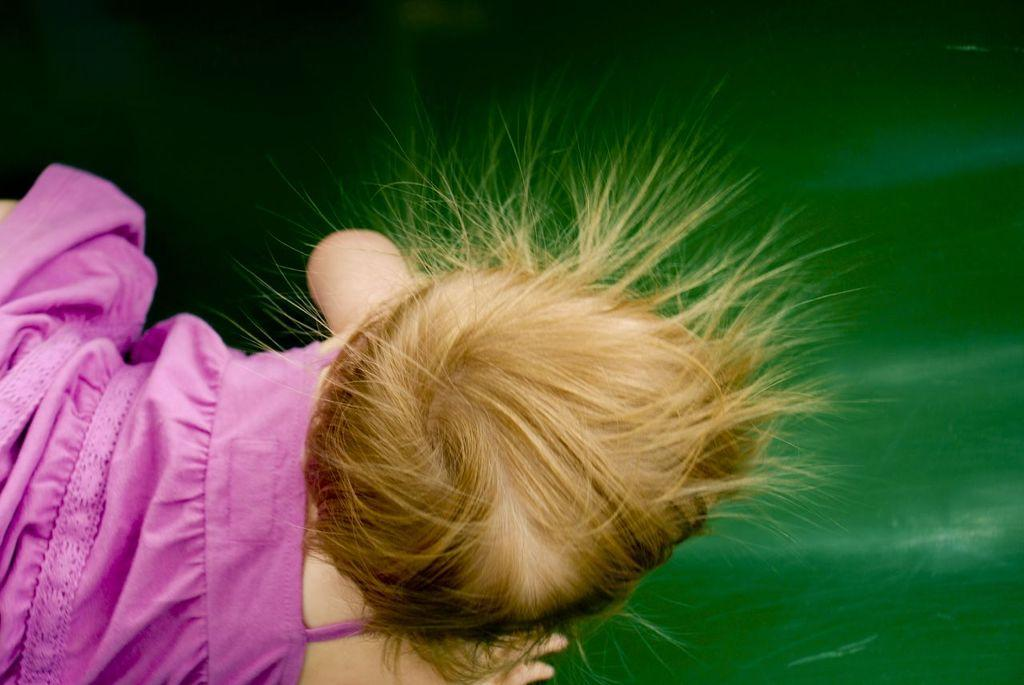What is the main subject of the image? The main subject of the image is a baby. Can you describe the baby's attire in the image? The baby is in a pink dress. What type of flame can be seen on the baby's head in the image? There is no flame present on the baby's head in the image. What type of quilt is covering the baby in the image? There is no quilt present in the image; the baby is wearing a pink dress. 